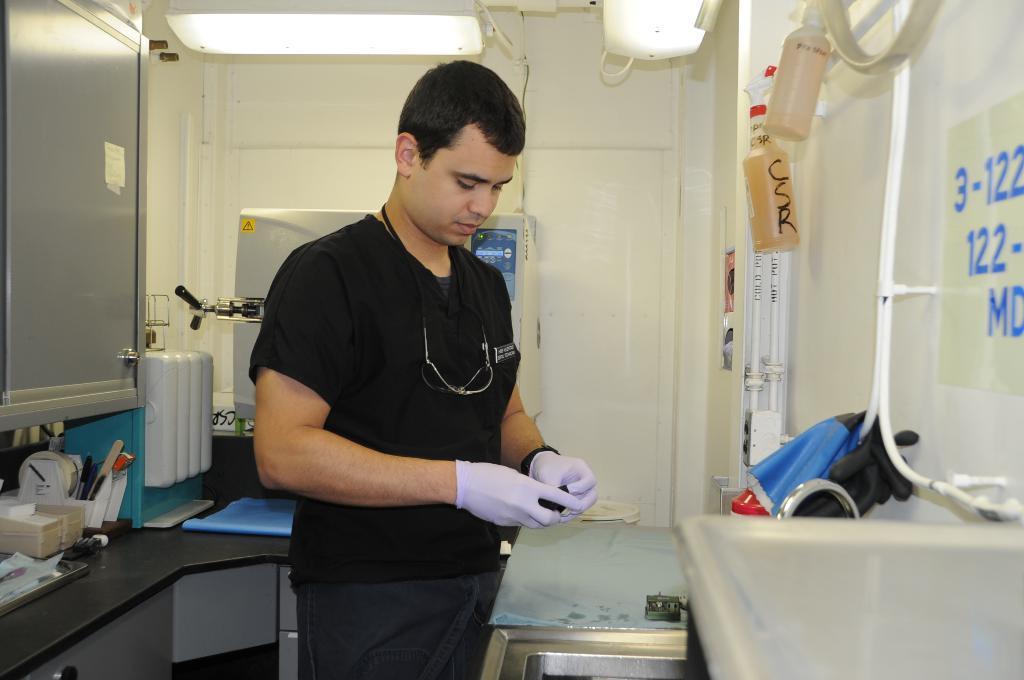Please provide a concise description of this image. In this image I can see a person standing. I can see some objects on the table. At the top I can see the lights. 